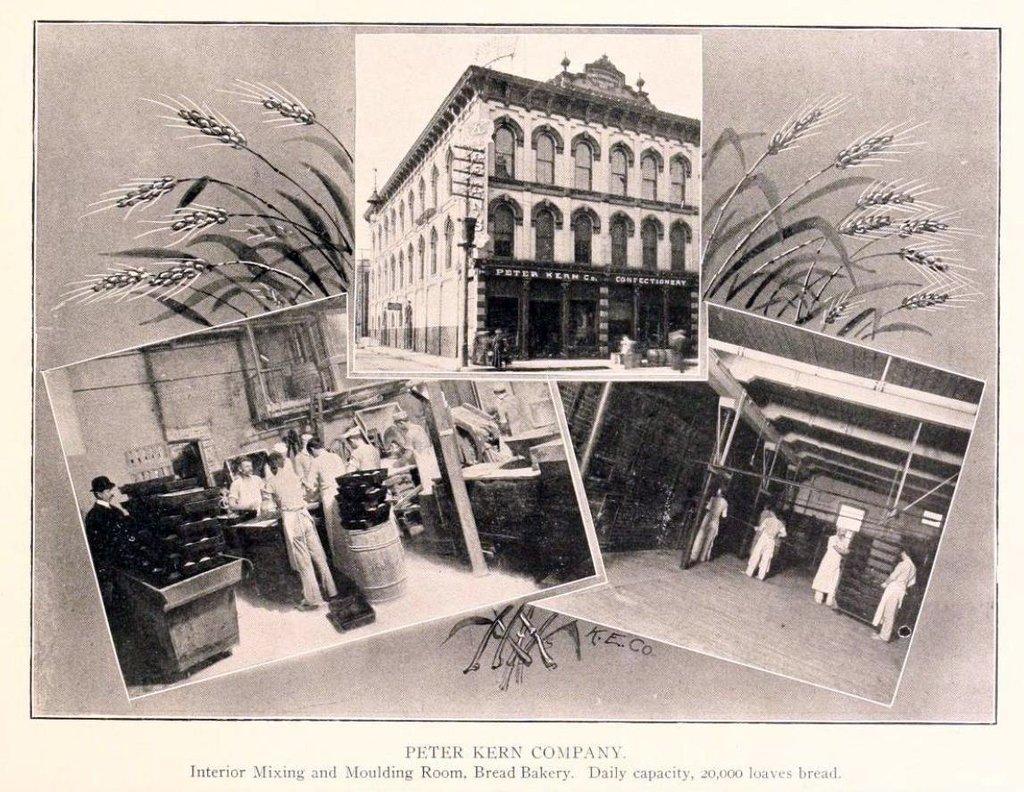Could you give a brief overview of what you see in this image? In this image we can see the collage black and white pictures. In this we can see a building and a group of people standing on the floor. On the backside we can see the picture of a plant. On the bottom of the image we can see some text. 